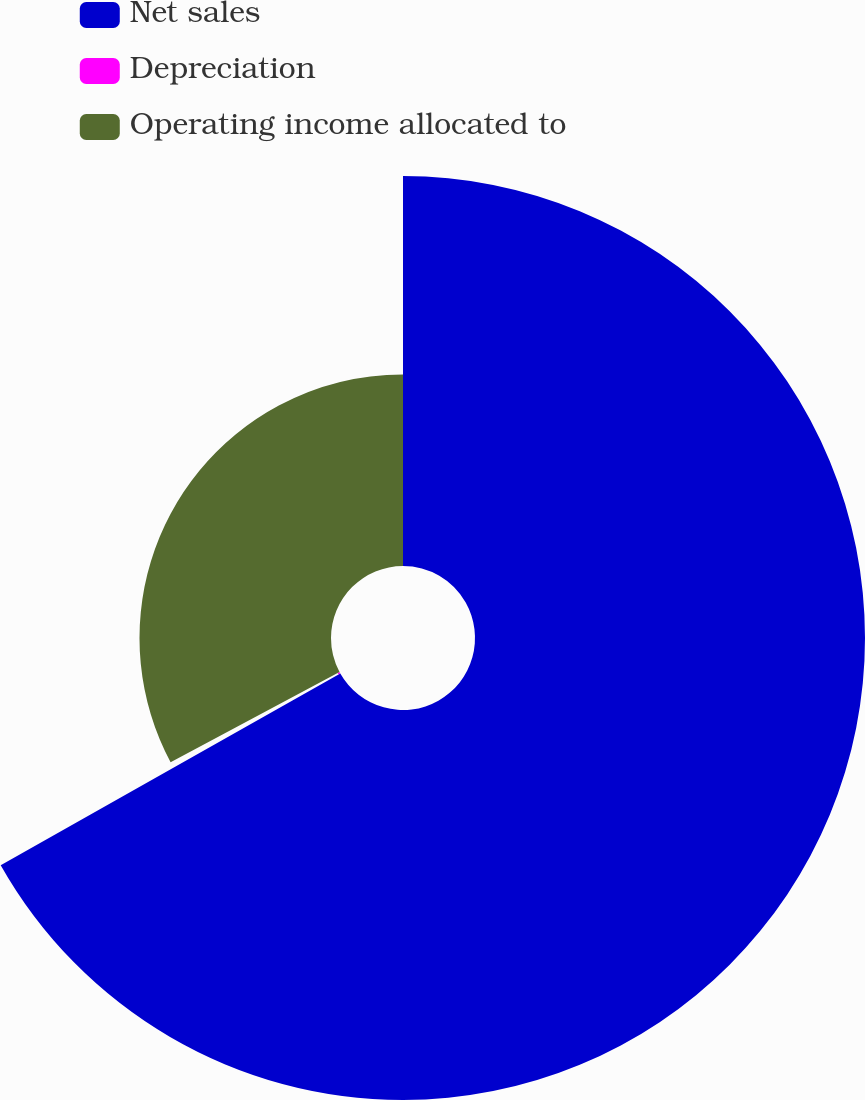<chart> <loc_0><loc_0><loc_500><loc_500><pie_chart><fcel>Net sales<fcel>Depreciation<fcel>Operating income allocated to<nl><fcel>66.82%<fcel>0.37%<fcel>32.81%<nl></chart> 